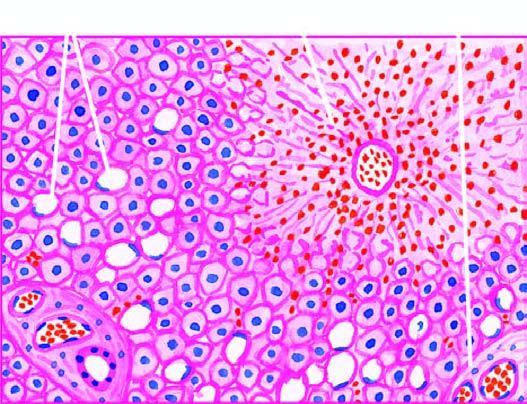does the periphery show marked degeneration and necrosis of hepatocytes accompanied by haemorrhage while the peripheral zone shows mild fatty change of liver cells?
Answer the question using a single word or phrase. No 